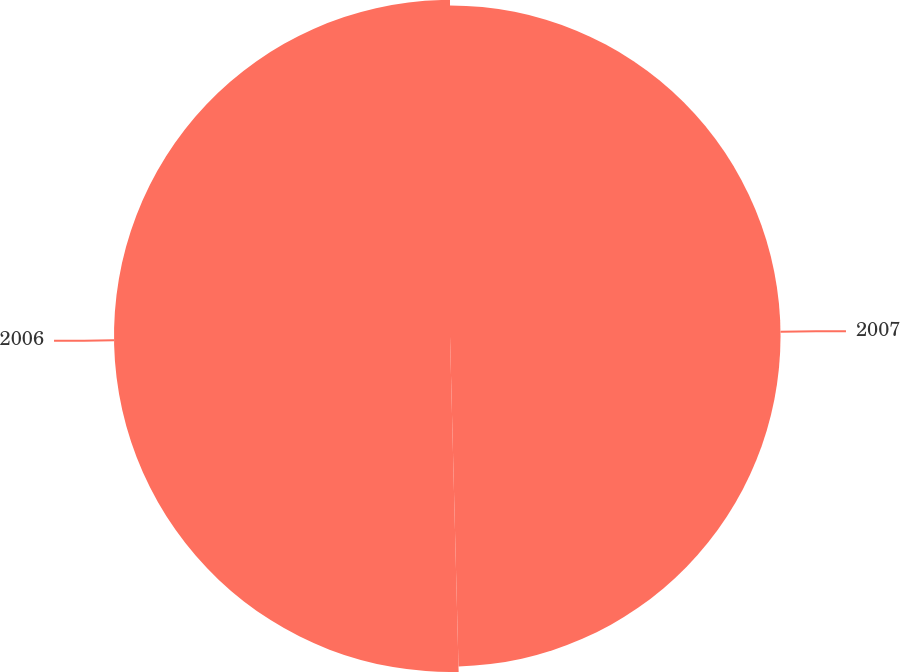Convert chart to OTSL. <chart><loc_0><loc_0><loc_500><loc_500><pie_chart><fcel>2007<fcel>2006<nl><fcel>49.59%<fcel>50.41%<nl></chart> 